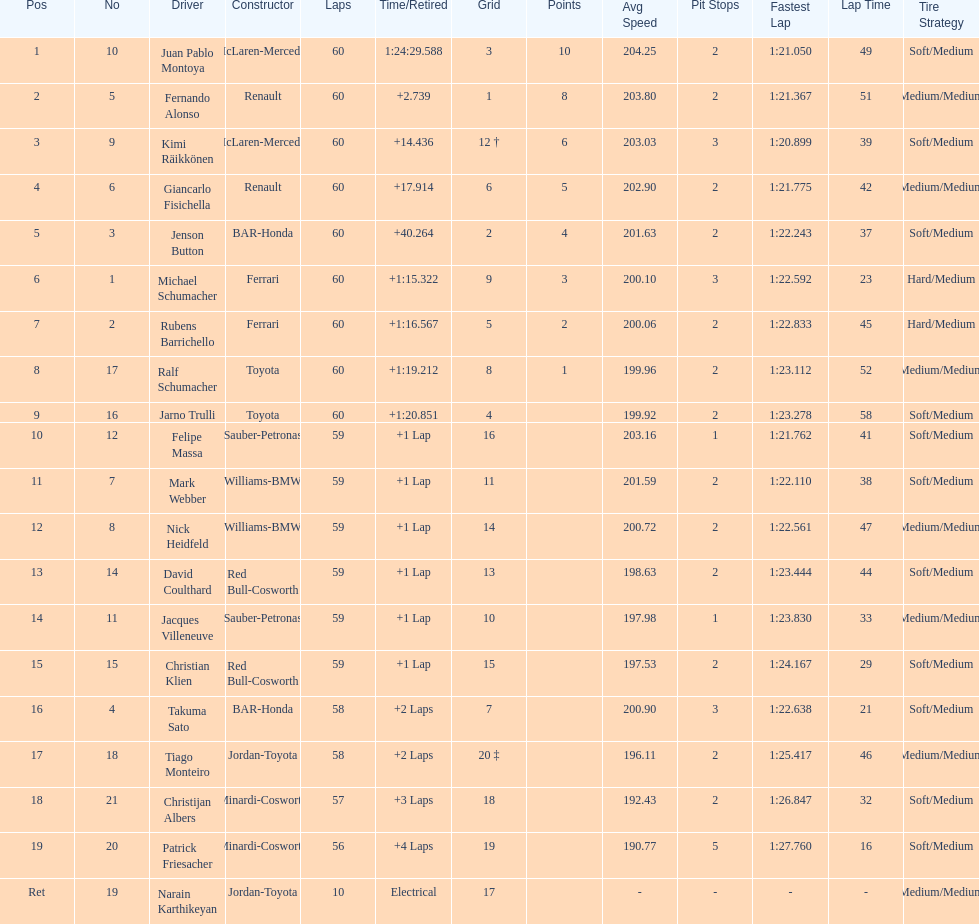Which driver has the least amount of points? Ralf Schumacher. 